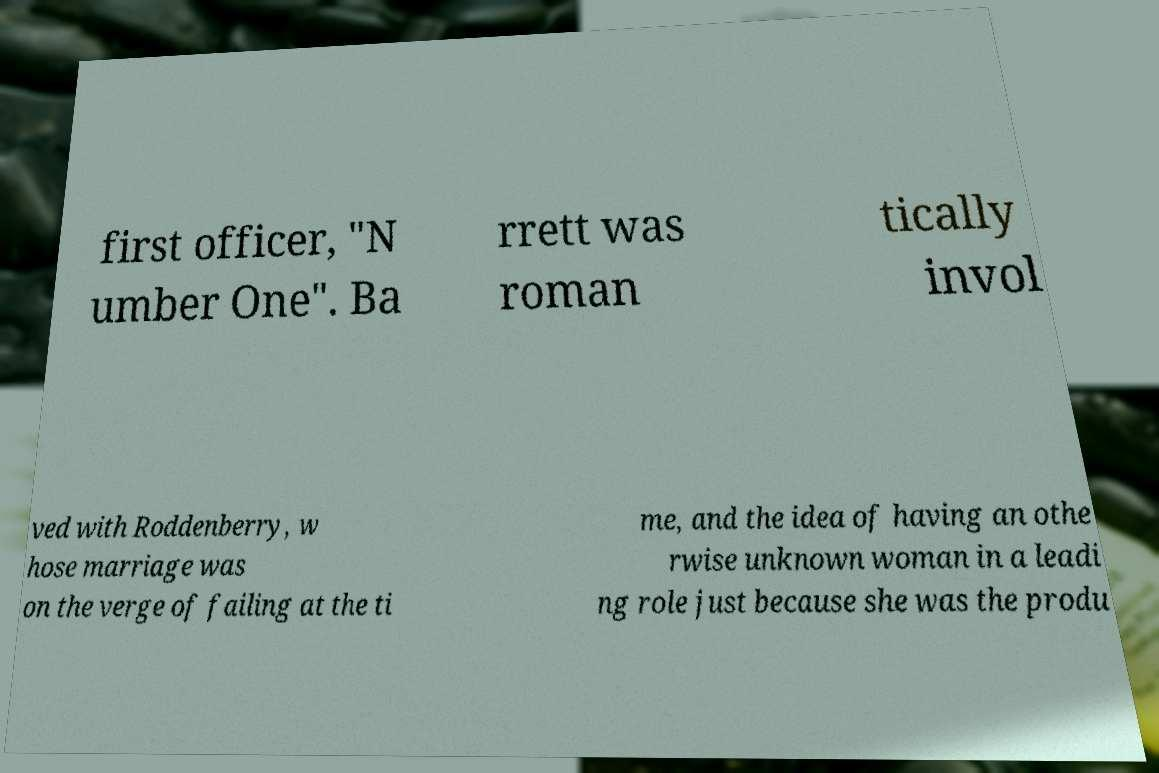Could you assist in decoding the text presented in this image and type it out clearly? first officer, "N umber One". Ba rrett was roman tically invol ved with Roddenberry, w hose marriage was on the verge of failing at the ti me, and the idea of having an othe rwise unknown woman in a leadi ng role just because she was the produ 